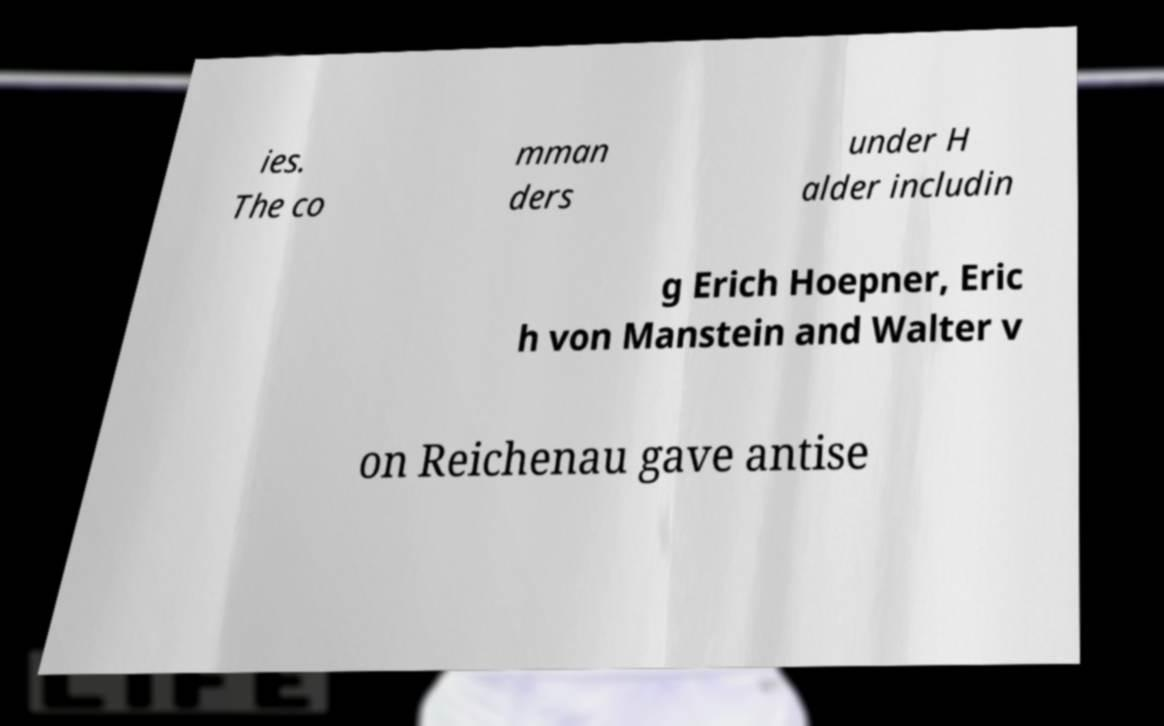I need the written content from this picture converted into text. Can you do that? ies. The co mman ders under H alder includin g Erich Hoepner, Eric h von Manstein and Walter v on Reichenau gave antise 